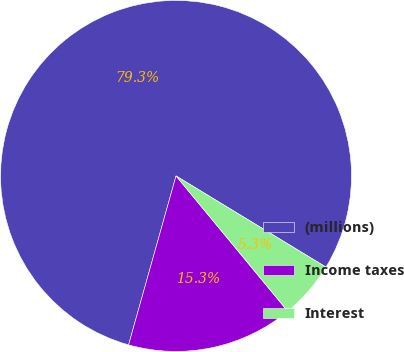Convert chart. <chart><loc_0><loc_0><loc_500><loc_500><pie_chart><fcel>(millions)<fcel>Income taxes<fcel>Interest<nl><fcel>79.33%<fcel>15.34%<fcel>5.32%<nl></chart> 